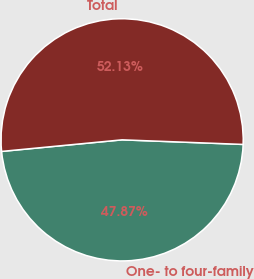<chart> <loc_0><loc_0><loc_500><loc_500><pie_chart><fcel>One- to four-family<fcel>Total<nl><fcel>47.87%<fcel>52.13%<nl></chart> 